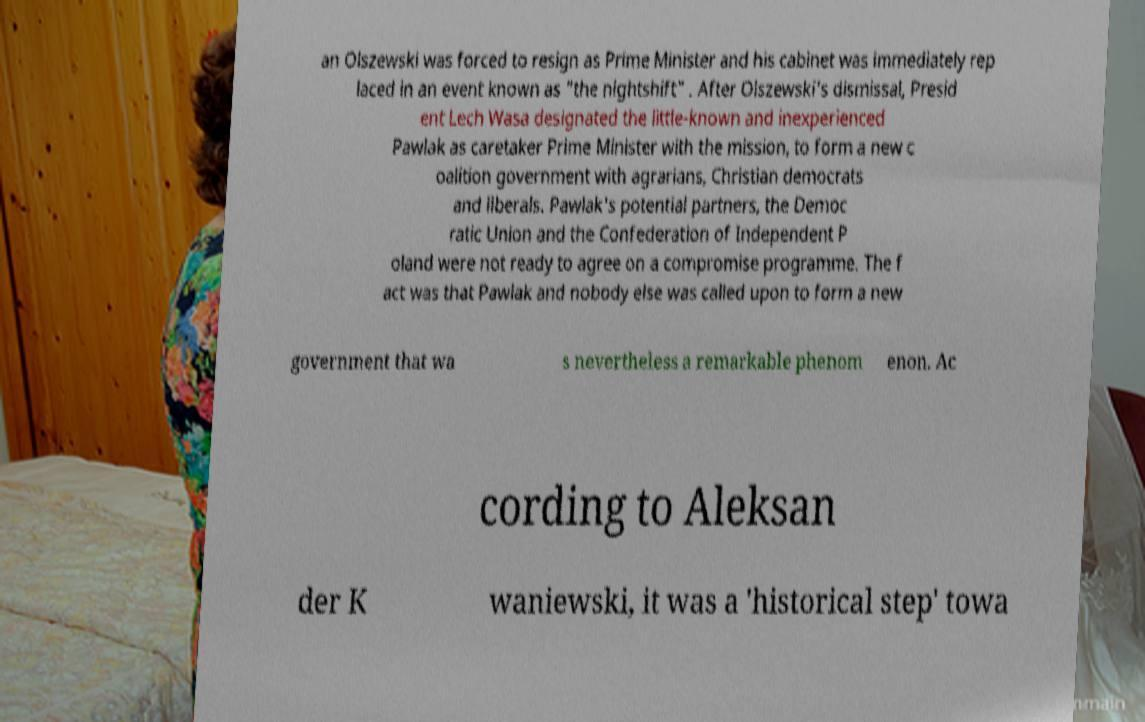For documentation purposes, I need the text within this image transcribed. Could you provide that? an Olszewski was forced to resign as Prime Minister and his cabinet was immediately rep laced in an event known as "the nightshift" . After Olszewski's dismissal, Presid ent Lech Wasa designated the little-known and inexperienced Pawlak as caretaker Prime Minister with the mission, to form a new c oalition government with agrarians, Christian democrats and liberals. Pawlak's potential partners, the Democ ratic Union and the Confederation of Independent P oland were not ready to agree on a compromise programme. The f act was that Pawlak and nobody else was called upon to form a new government that wa s nevertheless a remarkable phenom enon. Ac cording to Aleksan der K waniewski, it was a 'historical step' towa 